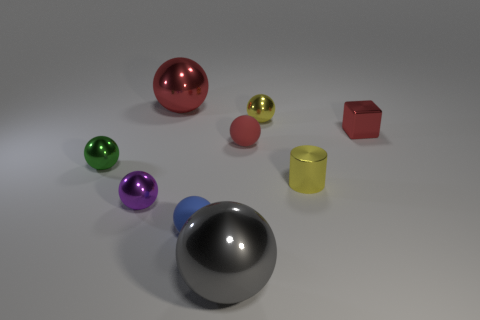Is the color of the small shiny sphere on the right side of the big red metal thing the same as the shiny cylinder?
Keep it short and to the point. Yes. What number of yellow things are metallic balls or matte blocks?
Provide a short and direct response. 1. There is a large metallic object behind the tiny ball that is in front of the tiny purple ball; what color is it?
Offer a very short reply. Red. There is a sphere that is the same color as the cylinder; what is it made of?
Ensure brevity in your answer.  Metal. There is a tiny rubber ball in front of the metal cylinder; what is its color?
Keep it short and to the point. Blue. Do the rubber thing behind the purple shiny object and the large gray thing have the same size?
Your answer should be compact. No. The metal ball that is the same color as the tiny block is what size?
Your answer should be very brief. Large. Are there any red blocks that have the same size as the gray ball?
Provide a succinct answer. No. Do the tiny metal sphere that is right of the big gray thing and the shiny cylinder in front of the tiny green ball have the same color?
Offer a very short reply. Yes. Are there any shiny balls that have the same color as the small cylinder?
Provide a short and direct response. Yes. 